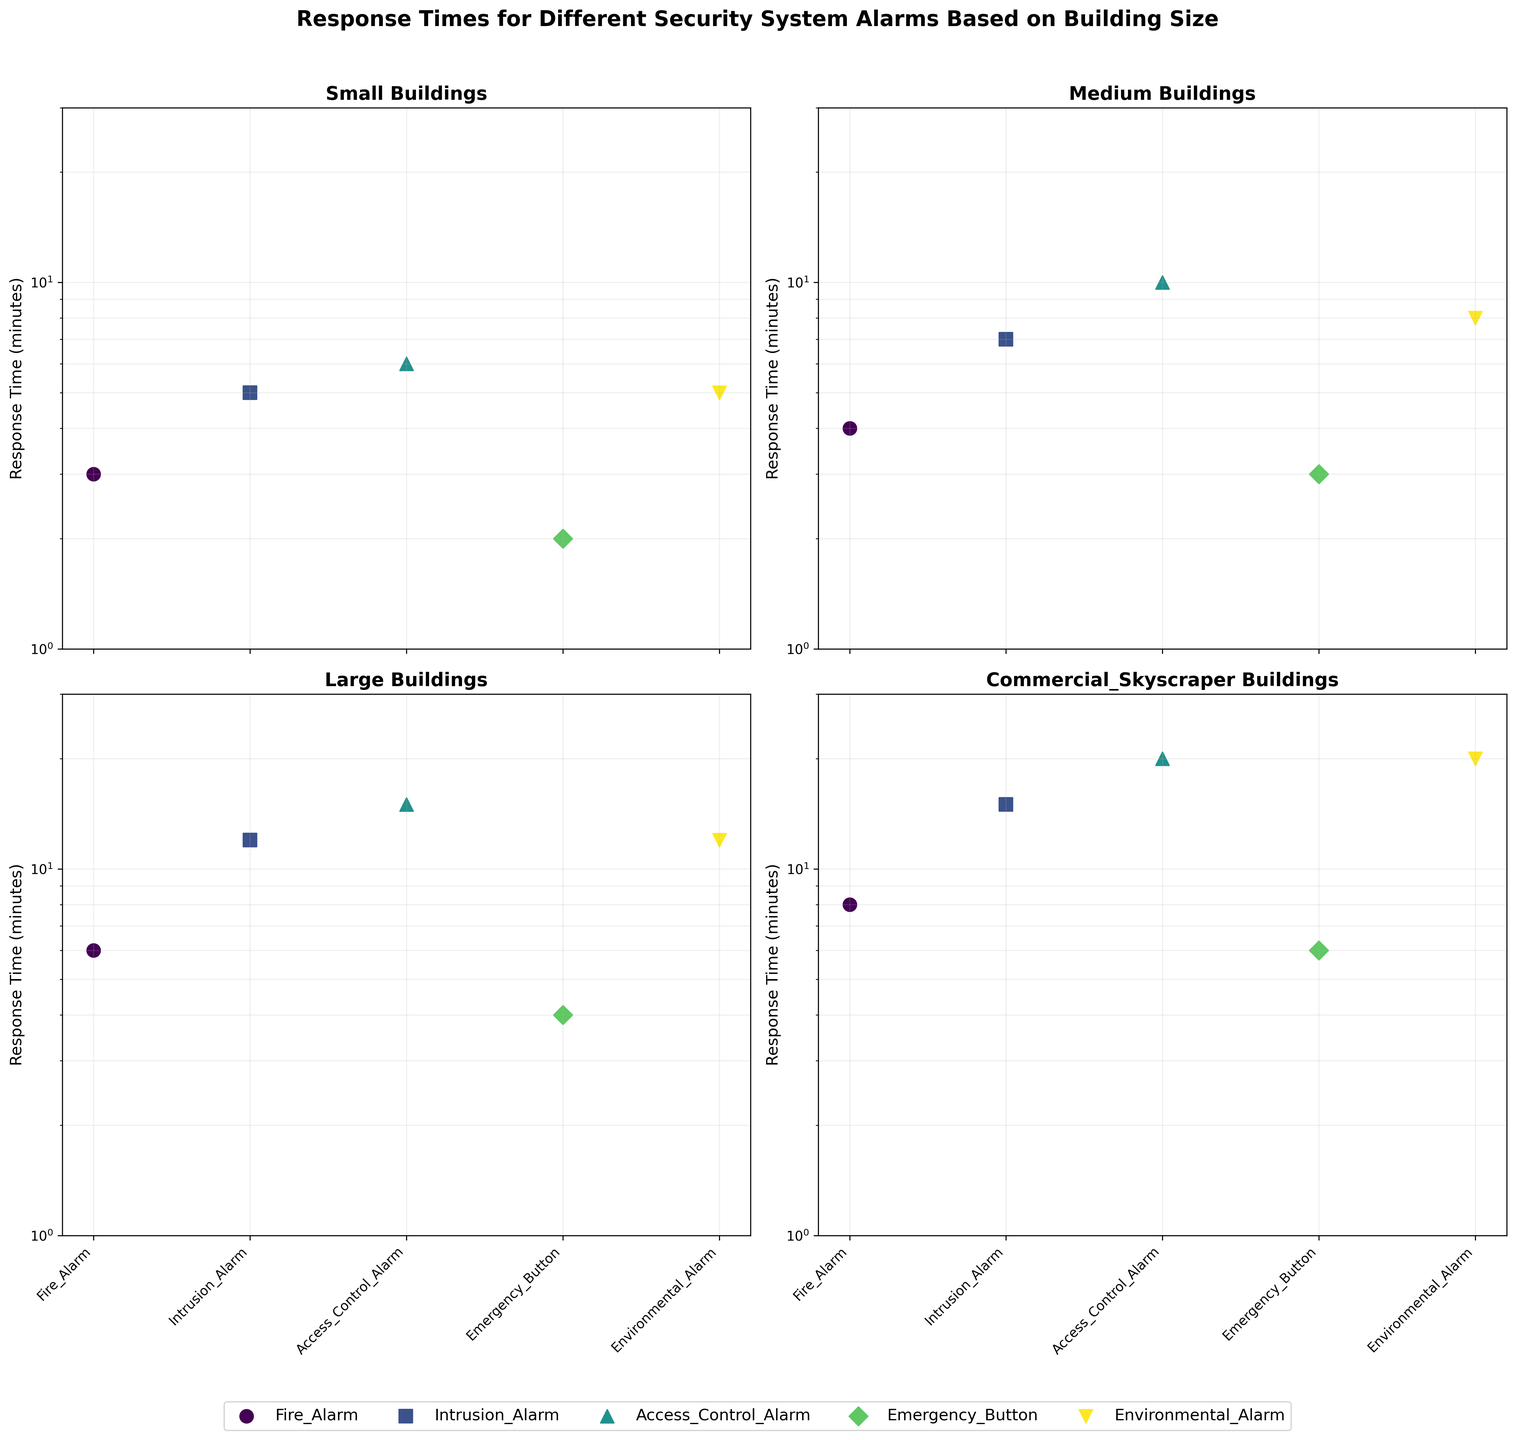What is the average response time for Fire Alarms in Medium buildings? Looking at the subplot labeled 'Medium Buildings', observe the data point for 'Fire Alarm' on the log-scale y-axis. The response time is 4 minutes.
Answer: 4 minutes How does the response time for Environmental Alarms in Large buildings compare to those in Commercial Skyscrapers? On the 'Large Buildings' subplot, the point for 'Environmental Alarm' shows a response time of 12 minutes. On the 'Commercial Skyscraper' subplot, the point for 'Environmental Alarm' shows a response time of 20 minutes. Since 20 is greater than 12, the response time in Commercial Skyscrapers is longer.
Answer: Longer Which building size has the shortest average response time for Emergency Button alarms? Examine all subplots for the data points labeled 'Emergency Button'. For Small buildings, the time is 2 minutes; for Medium buildings, it is 3 minutes; for Large buildings, it is 4 minutes; for Commercial Skyscrapers, it is 6 minutes. The smallest time is in Small buildings.
Answer: Small What is the difference in response time between Access Control Alarms and Intrusion Alarms in Medium buildings? In the 'Medium Buildings' subplot, find the data points for 'Access Control Alarm' (10 minutes) and 'Intrusion Alarm' (7 minutes). Subtract 7 from 10 to get the difference.
Answer: 3 minutes Which type of alarm has the most significant variance in response times across all building sizes? Compare the response times for each alarm type across different subplots. 'Access Control Alarm' ranges from 6 minutes (Small) to 20 minutes (Commercial Skyscraper), showing the most significant variation of 14 minutes.
Answer: Access Control Alarm Are the response times for Fire Alarms consistent or varying significantly across different building sizes? Evaluate the Fire Alarm data points in each subplot: Small (3 minutes), Medium (4 minutes), Large (6 minutes), Commercial Skyscraper (8 minutes). The times increase but not drastically, indicating some variation but not extreme.
Answer: Varying slightly In which building size does Intrusion Alarm has the longest response time? Check all subplots for the data points labeled 'Intrusion Alarm'. For Small buildings, the time is 5 minutes; for Medium buildings, it is 7 minutes; for Large buildings, it is 12 minutes; for Commercial Skyscrapers, it is 15 minutes. The longest time is in Commercial Skyscrapers.
Answer: Commercial Skyscraper What is the combined response time for all alarms in Small buildings? For the 'Small Buildings' subplot, sum the response times for all alarms: 3 (Fire Alarm) + 5 (Intrusion Alarm) + 6 (Access Control Alarm) + 2 (Emergency Button) + 5 (Environmental Alarm). The total is 21 minutes.
Answer: 21 minutes How does the median response time for alarms in Large buildings compare to Small buildings? List the response times for Large buildings: 6 (Fire Alarm), 12 (Intrusion Alarm), 15 (Access Control Alarm), 4 (Emergency Button), 12 (Environmental Alarm). Median is 12. For Small buildings: 3 (Fire Alarm), 5 (Intrusion Alarm), 6 (Access Control Alarm), 2 (Emergency Button), 5 (Environmental Alarm). Median is 5. Large buildings have a higher median.
Answer: Higher How many types of alarms are analyzed in the figure? Count the unique alarm types labeled along the x-axis of any subplot. The types are Fire Alarm, Intrusion Alarm, Access Control Alarm, Emergency Button, and Environmental Alarm. There are 5 types in total.
Answer: 5 